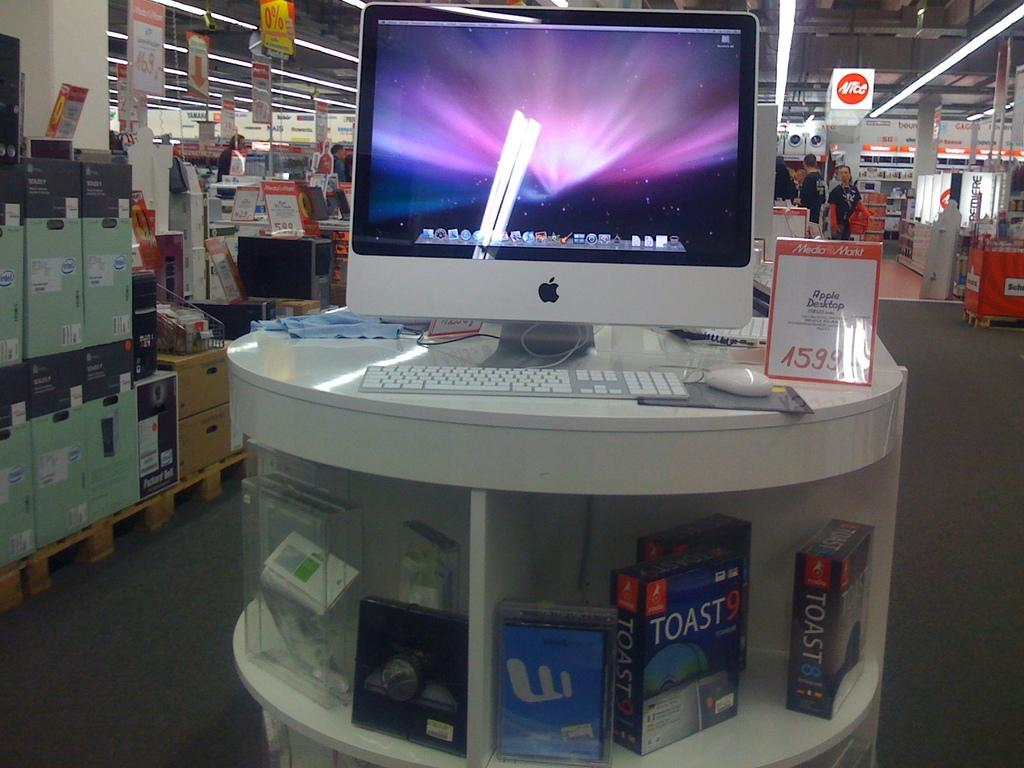Provide a one-sentence caption for the provided image. The Apple Desktop store display includes Toast software versions 8 and 9. 